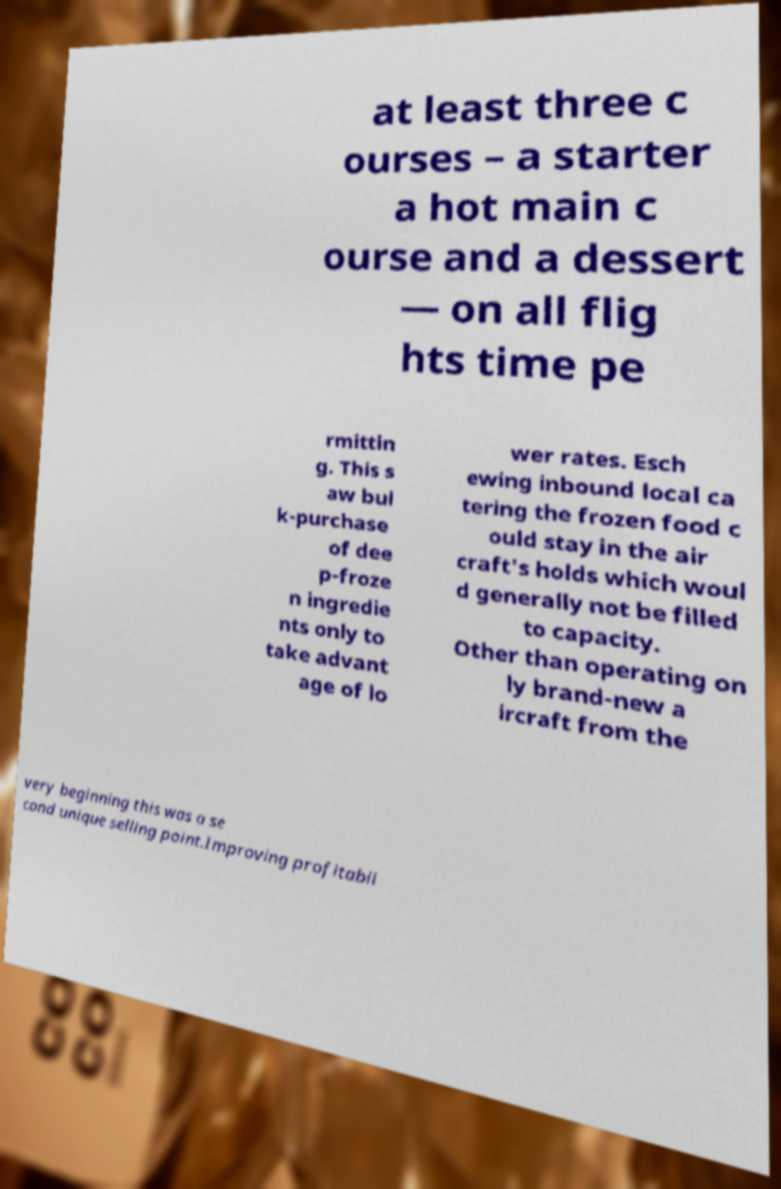Please read and relay the text visible in this image. What does it say? at least three c ourses – a starter a hot main c ourse and a dessert — on all flig hts time pe rmittin g. This s aw bul k-purchase of dee p-froze n ingredie nts only to take advant age of lo wer rates. Esch ewing inbound local ca tering the frozen food c ould stay in the air craft's holds which woul d generally not be filled to capacity. Other than operating on ly brand-new a ircraft from the very beginning this was a se cond unique selling point.Improving profitabil 